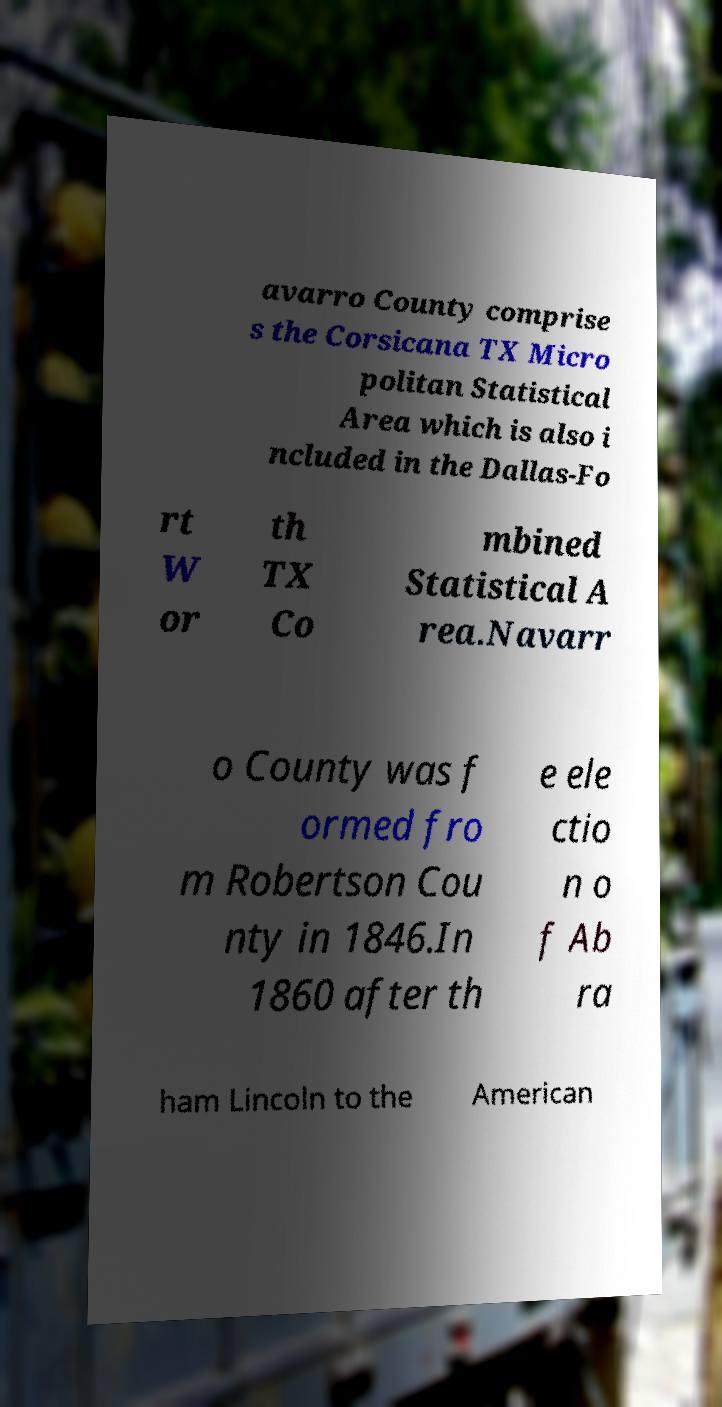For documentation purposes, I need the text within this image transcribed. Could you provide that? avarro County comprise s the Corsicana TX Micro politan Statistical Area which is also i ncluded in the Dallas-Fo rt W or th TX Co mbined Statistical A rea.Navarr o County was f ormed fro m Robertson Cou nty in 1846.In 1860 after th e ele ctio n o f Ab ra ham Lincoln to the American 